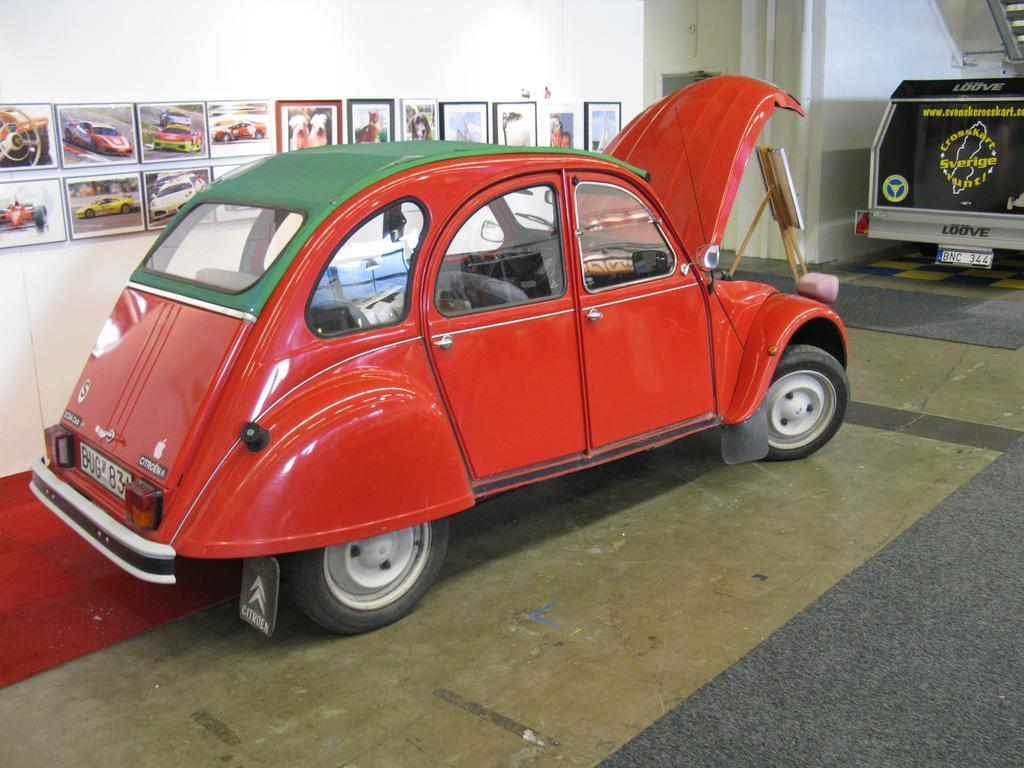What color is the car in the image? The car in the image is red. Where is the red car located in the image? The red car is on the floor. What can be seen on the wall behind the car? There are photographs on the wall behind the car. What other architectural feature is visible in the image? There is a door visible in the image. What other vehicle can be seen in the image? There is another vehicle in the image. Can you tell me how many breaths the car takes in the image? Cars do not breathe, so this question cannot be answered. 